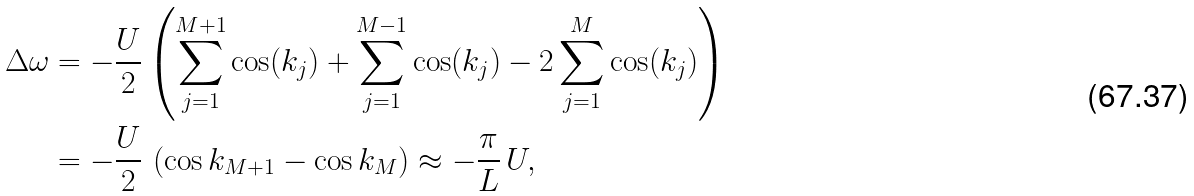<formula> <loc_0><loc_0><loc_500><loc_500>\Delta \omega & = - \frac { U } { 2 } \left ( \sum _ { j = 1 } ^ { M + 1 } \cos ( k _ { j } ) + \sum _ { j = 1 } ^ { M - 1 } \cos ( k _ { j } ) - 2 \sum _ { j = 1 } ^ { M } \cos ( k _ { j } ) \right ) \\ & = - \frac { U } { 2 } \, \left ( \cos k _ { M + 1 } - \cos k _ { M } \right ) \approx - \frac { \pi } { L } \, U ,</formula> 